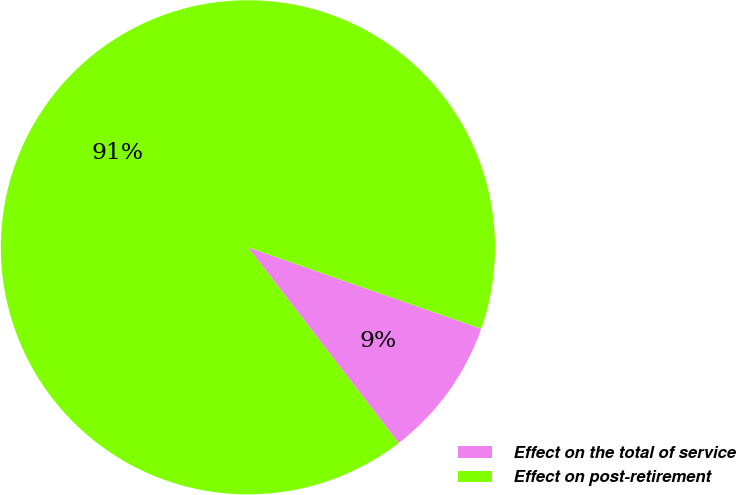<chart> <loc_0><loc_0><loc_500><loc_500><pie_chart><fcel>Effect on the total of service<fcel>Effect on post-retirement<nl><fcel>9.21%<fcel>90.79%<nl></chart> 